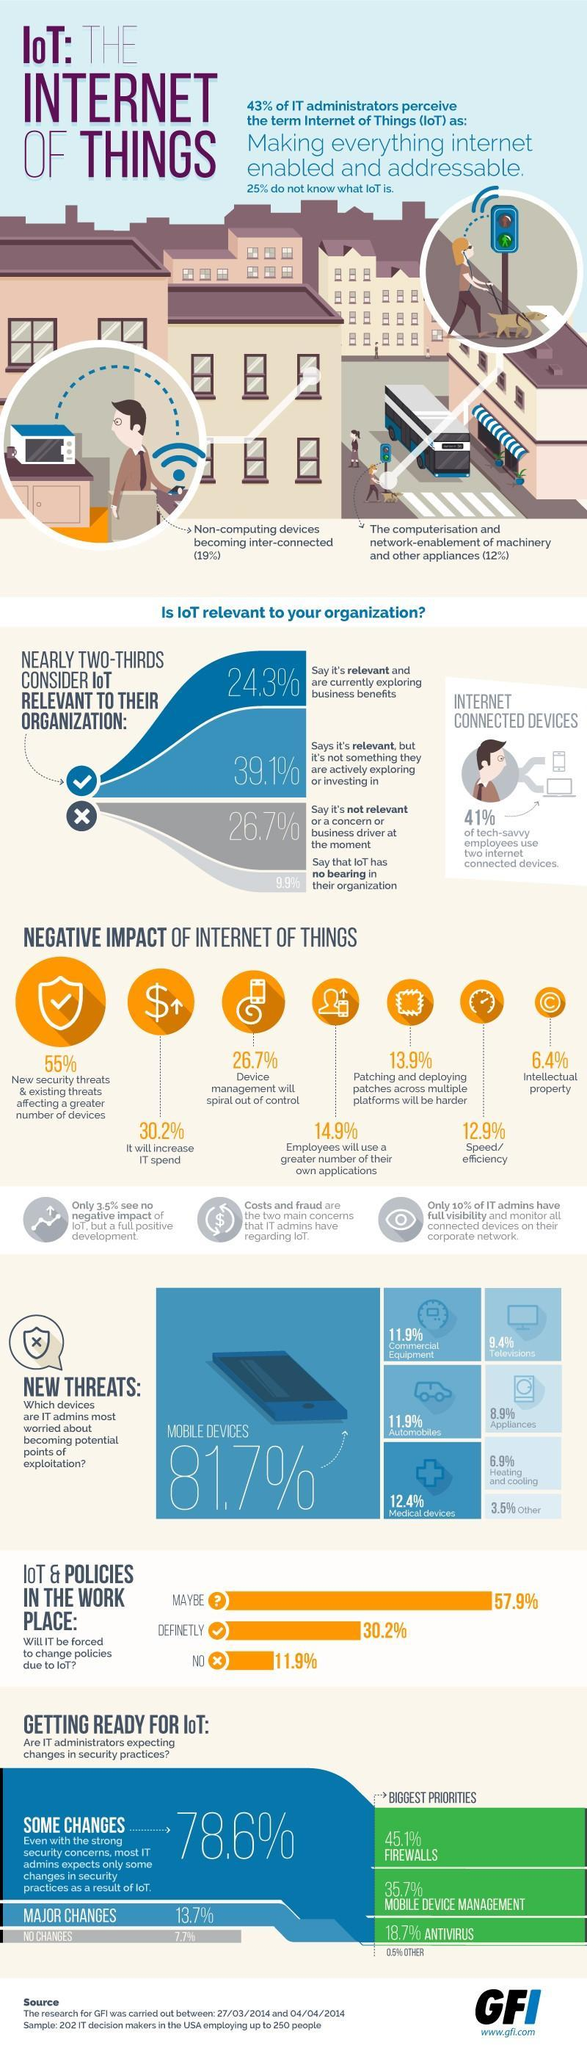Which is the second biggest priority in security practices?
Answer the question with a short phrase. MOBILE DEVICE MANAGEMENT What total percent of people say that IoT is relevant even if they are exploring it or not? 63.4% What percent of people do not use two internet connected devices? 59% Which two devices are seen as threats according to 11.9% of IT admins? Commercial Equipment, Automobiles 